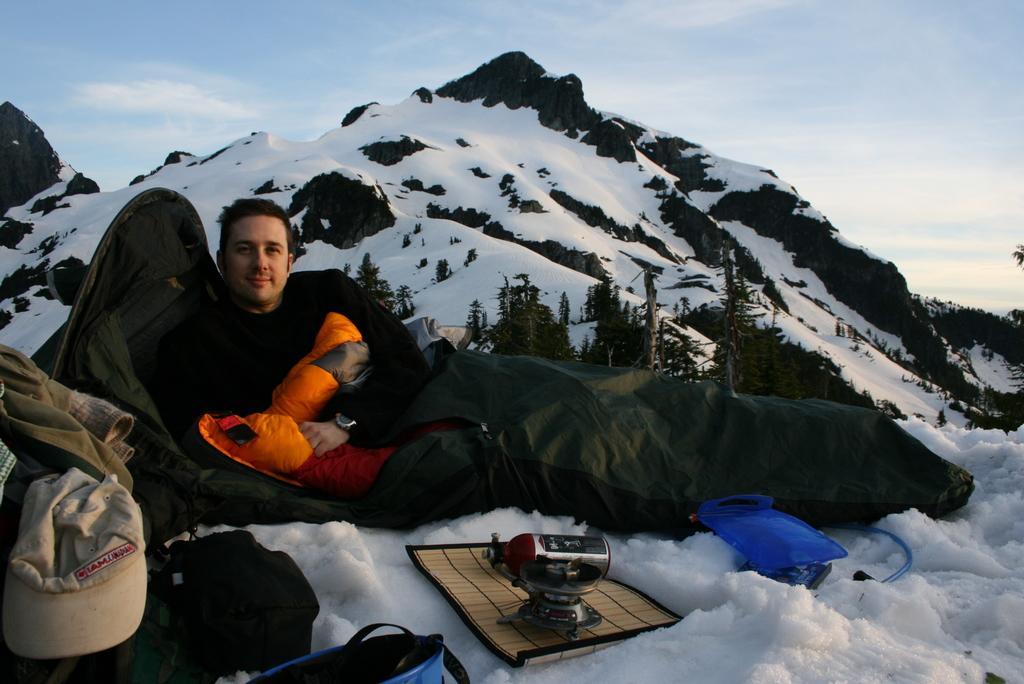Describe this image in one or two sentences. In the center of the image we can see a person lying down on the snow holding a cushion. We can also see a blanket on him. On the bottom of the image we can see some clothes, a device placed on a mat and a bag beside him. On the backside we can see the ice hills, a group of trees, the bark of a tree and the sky which looks cloudy. 